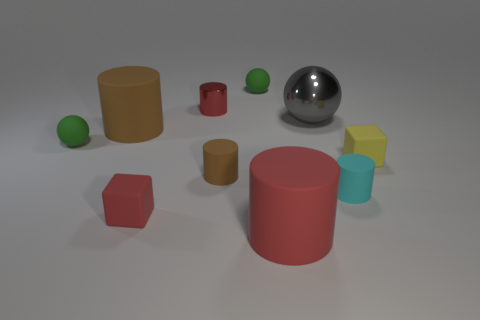Is the number of tiny shiny cylinders that are in front of the large red matte object less than the number of big brown things to the left of the cyan matte cylinder?
Make the answer very short. Yes. Are there any cyan things behind the yellow block?
Provide a short and direct response. No. Is there a green ball that is in front of the big rubber object that is behind the ball that is in front of the large shiny object?
Provide a succinct answer. Yes. There is a shiny thing left of the red rubber cylinder; is it the same shape as the big brown thing?
Provide a short and direct response. Yes. What color is the tiny object that is the same material as the big gray object?
Offer a terse response. Red. What number of tiny yellow cubes are made of the same material as the cyan cylinder?
Offer a terse response. 1. What color is the small rubber cylinder that is to the left of the red rubber thing that is to the right of the sphere behind the small red metallic thing?
Give a very brief answer. Brown. Is the size of the cyan rubber cylinder the same as the red matte block?
Ensure brevity in your answer.  Yes. Is there anything else that has the same shape as the cyan object?
Your answer should be very brief. Yes. What number of objects are yellow matte objects that are to the right of the big gray sphere or tiny balls?
Your response must be concise. 3. 